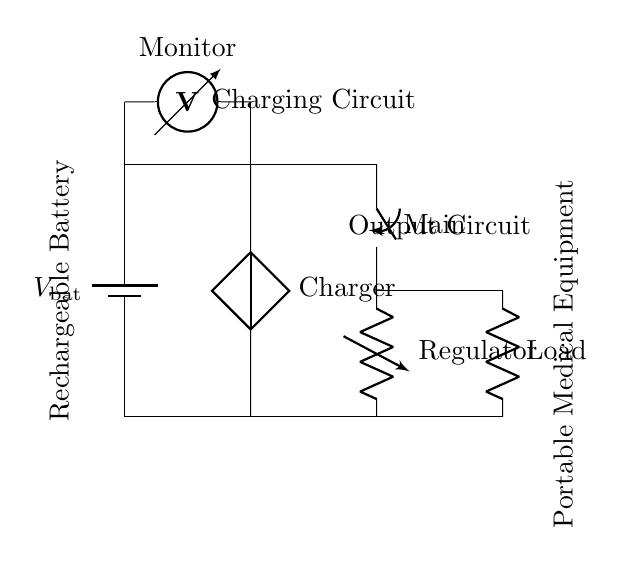What is the source of power in this circuit? The circuit diagram shows a battery labeled as the source of power, indicated by the battery symbol.
Answer: Battery What is the function of the component labeled "Charger"? The labeled component "Charger" is a current voltage source designed to recharge the battery when connected.
Answer: Current voltage source What is the role of the "Regulator" in the circuit? The "Regulator" ensures a stable voltage output from the circuit that is used to power the portable medical equipment.
Answer: Stabilization How many main components are visible in this circuit? Counting the battery, charger, switch, regulator, and load, there are five main components visible in the circuit.
Answer: Five What happens when the "Main" switch is open? When the "Main" switch is open, the circuit is incomplete, and no current flows to the portable medical equipment.
Answer: No current flow What does the "Monitor" measure in this circuit? The "Monitor" is a voltmeter that measures the voltage across the battery to ensure it's charged properly.
Answer: Voltage measurement What is connected to the load in the output circuit? The load connected at the output circuit is the portable medical equipment, which consumes the energy supplied.
Answer: Portable medical equipment 